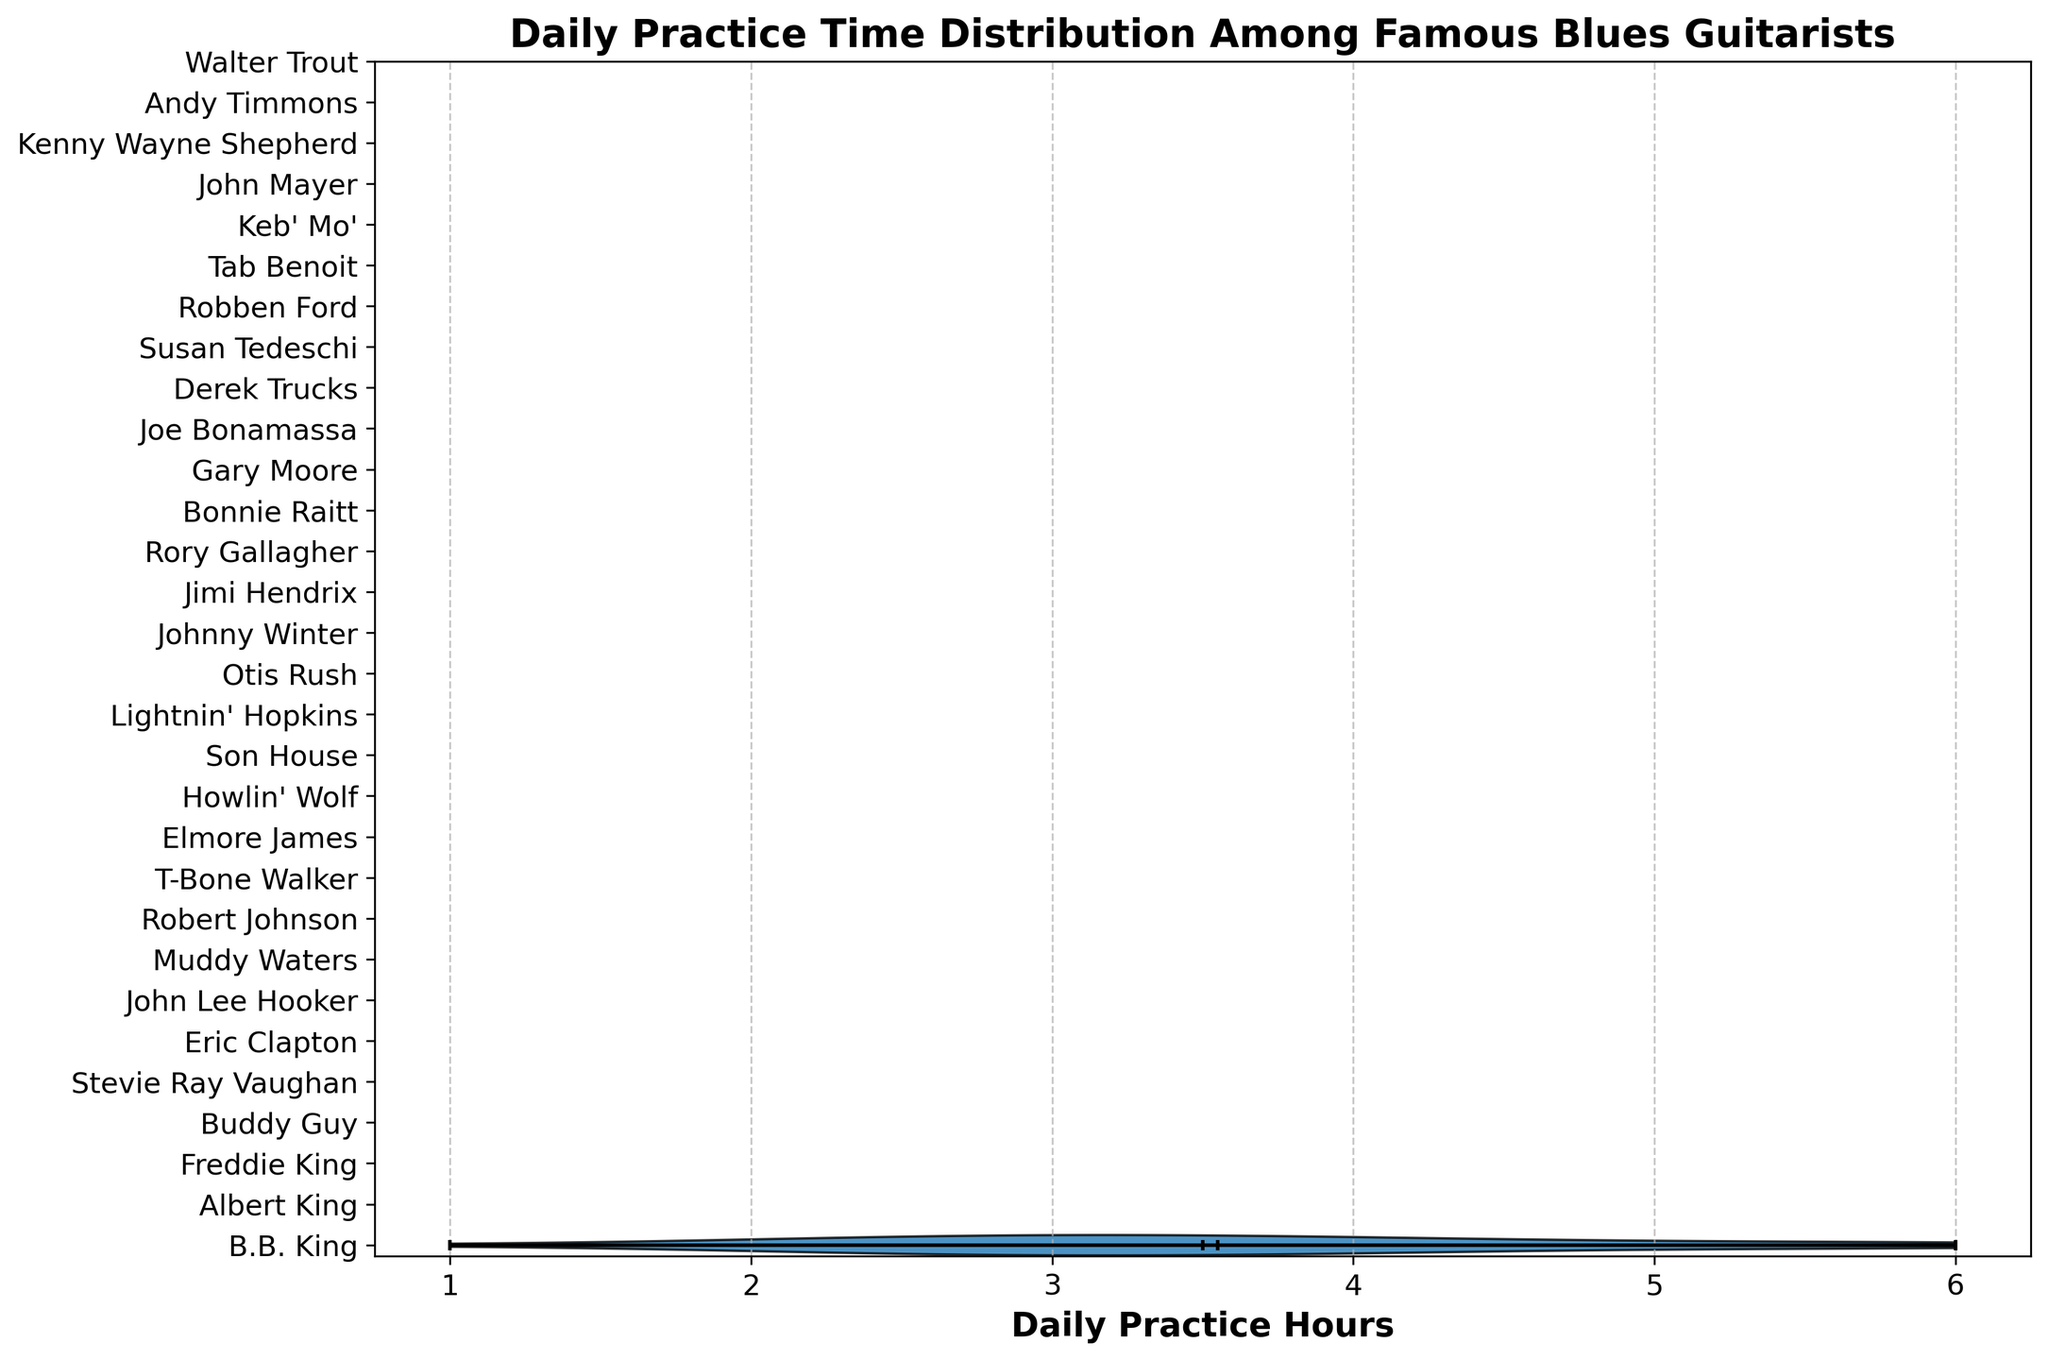What's the median daily practice time? The median is represented visually on the violin plot with a specific mark. Locate the mark indicating the median on the distribution.
Answer: 3.5 hours Which guitarist practices the most daily? Identify the musician at the highest end of the practice time distribution and check the corresponding label.
Answer: Stevie Ray Vaughan, Jimi Hendrix, Gary Moore (6 hours) How much more does Buddy Guy practice compared to B.B. King? Find the practice hours for both Buddy Guy and B.B. King from their respective positions on the plot. Subtract B.B. King's practice time from Buddy Guy's.
Answer: 2 hours Who practices less, John Lee Hooker or Son House? Compare the practice time for John Lee Hooker and Son House by locating their positions on the violin plot and checking their labels.
Answer: John Lee Hooker What is the average practice time among all the guitarists? Sum all the practice hours for the guitarists and divide by the number of guitarists. \(\text{Sum} = 101\), \(\text{Count} = 30\). Average = \(\frac{101}{30} \approx 3.37\).
Answer: 3.37 hours Between what range do the daily practice times mostly lie? Look at the overall spread captured by the violin plot, from the lowest to the highest value.
Answer: 1 to 6 hours 